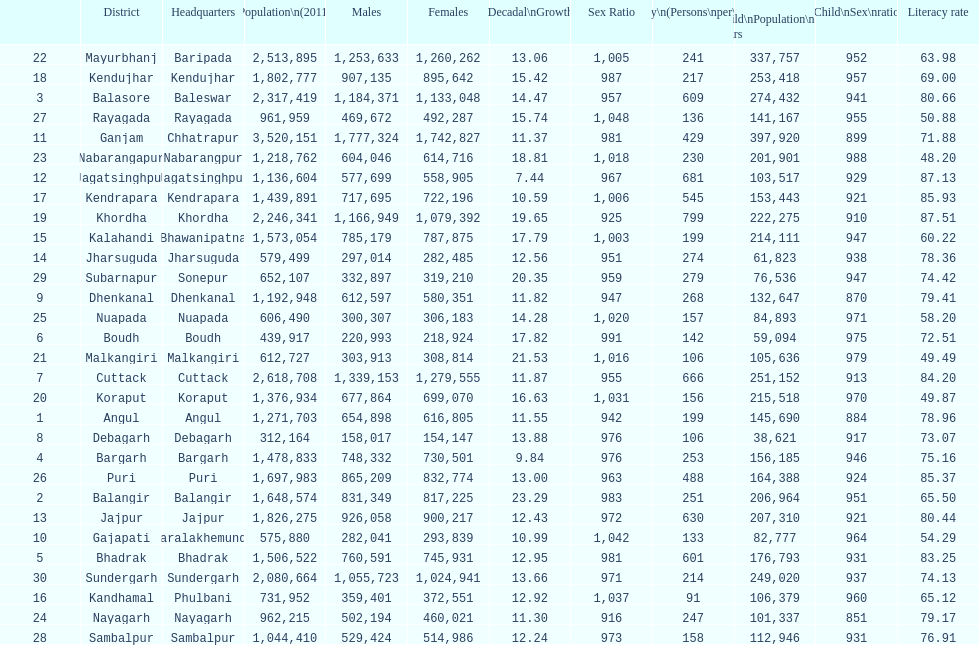Which district has a higher population, angul or cuttack? Cuttack. 